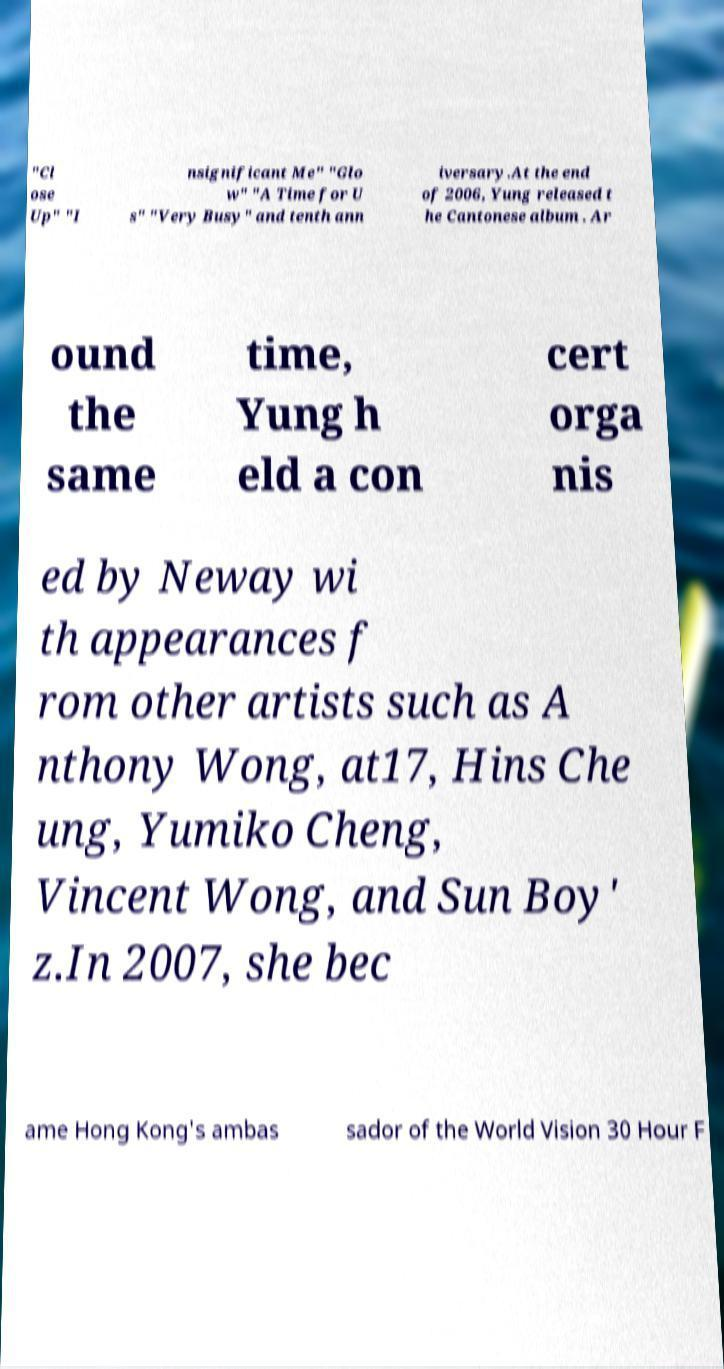Can you read and provide the text displayed in the image?This photo seems to have some interesting text. Can you extract and type it out for me? "Cl ose Up" "I nsignificant Me" "Glo w" "A Time for U s" "Very Busy" and tenth ann iversary.At the end of 2006, Yung released t he Cantonese album . Ar ound the same time, Yung h eld a con cert orga nis ed by Neway wi th appearances f rom other artists such as A nthony Wong, at17, Hins Che ung, Yumiko Cheng, Vincent Wong, and Sun Boy' z.In 2007, she bec ame Hong Kong's ambas sador of the World Vision 30 Hour F 